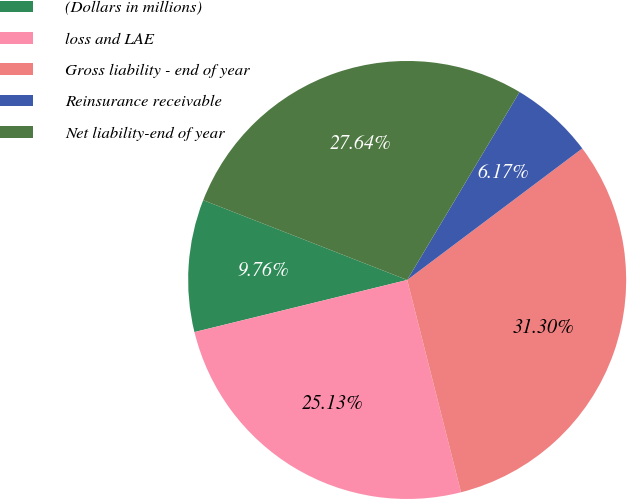Convert chart. <chart><loc_0><loc_0><loc_500><loc_500><pie_chart><fcel>(Dollars in millions)<fcel>loss and LAE<fcel>Gross liability - end of year<fcel>Reinsurance receivable<fcel>Net liability-end of year<nl><fcel>9.76%<fcel>25.13%<fcel>31.3%<fcel>6.17%<fcel>27.64%<nl></chart> 